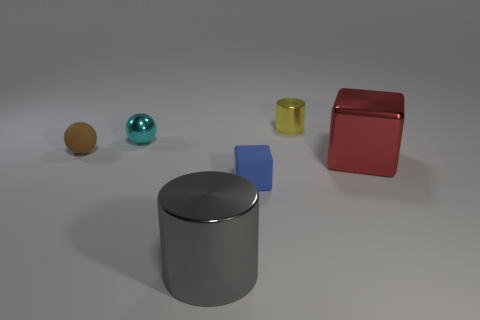What number of other objects are the same material as the small cyan thing?
Make the answer very short. 3. Does the cylinder that is to the left of the blue object have the same material as the tiny cyan object?
Make the answer very short. Yes. Is the number of gray metal objects behind the blue object greater than the number of large gray things that are on the left side of the small brown sphere?
Your response must be concise. No. What number of things are either small matte objects that are in front of the red metal thing or small shiny balls?
Your answer should be compact. 2. The brown thing that is made of the same material as the tiny blue object is what shape?
Make the answer very short. Sphere. Are there any other things that are the same shape as the small cyan object?
Provide a short and direct response. Yes. There is a object that is to the right of the tiny rubber block and in front of the tiny shiny cylinder; what is its color?
Give a very brief answer. Red. What number of cylinders are large green things or large red shiny objects?
Offer a terse response. 0. What number of gray cylinders are the same size as the red metal thing?
Ensure brevity in your answer.  1. There is a cylinder that is in front of the matte cube; what number of gray cylinders are behind it?
Your answer should be compact. 0. 